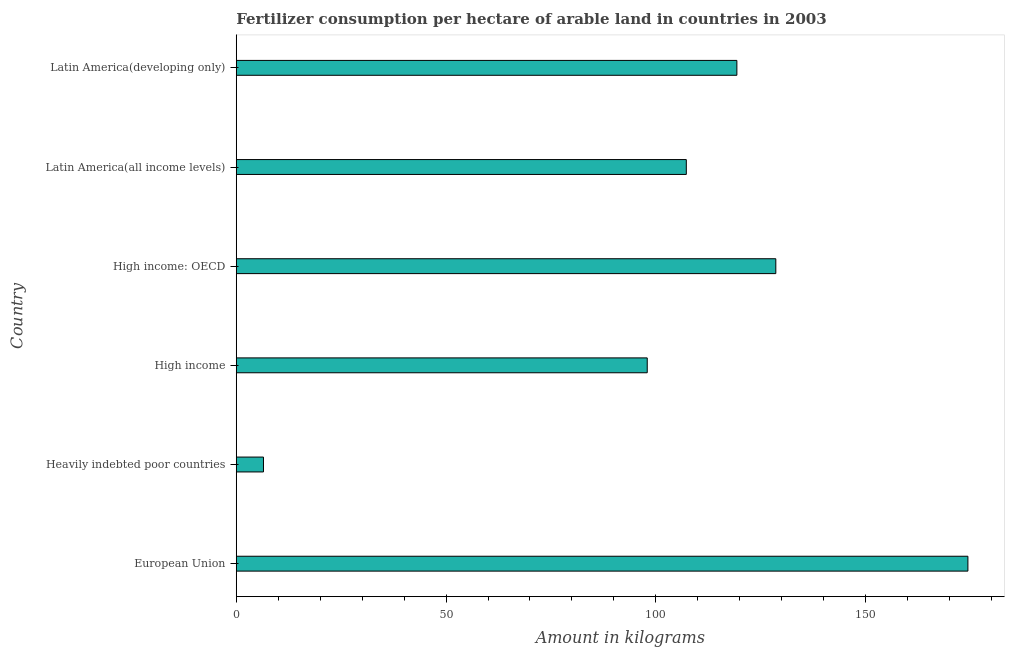Does the graph contain grids?
Provide a succinct answer. No. What is the title of the graph?
Offer a very short reply. Fertilizer consumption per hectare of arable land in countries in 2003 . What is the label or title of the X-axis?
Make the answer very short. Amount in kilograms. What is the amount of fertilizer consumption in Heavily indebted poor countries?
Provide a short and direct response. 6.48. Across all countries, what is the maximum amount of fertilizer consumption?
Ensure brevity in your answer.  174.38. Across all countries, what is the minimum amount of fertilizer consumption?
Ensure brevity in your answer.  6.48. In which country was the amount of fertilizer consumption maximum?
Provide a short and direct response. European Union. In which country was the amount of fertilizer consumption minimum?
Make the answer very short. Heavily indebted poor countries. What is the sum of the amount of fertilizer consumption?
Give a very brief answer. 633.98. What is the difference between the amount of fertilizer consumption in European Union and Latin America(developing only)?
Your response must be concise. 55.06. What is the average amount of fertilizer consumption per country?
Offer a terse response. 105.66. What is the median amount of fertilizer consumption?
Give a very brief answer. 113.29. In how many countries, is the amount of fertilizer consumption greater than 30 kg?
Offer a terse response. 5. What is the ratio of the amount of fertilizer consumption in European Union to that in High income: OECD?
Keep it short and to the point. 1.36. What is the difference between the highest and the second highest amount of fertilizer consumption?
Offer a terse response. 45.78. Is the sum of the amount of fertilizer consumption in European Union and High income: OECD greater than the maximum amount of fertilizer consumption across all countries?
Offer a very short reply. Yes. What is the difference between the highest and the lowest amount of fertilizer consumption?
Ensure brevity in your answer.  167.89. In how many countries, is the amount of fertilizer consumption greater than the average amount of fertilizer consumption taken over all countries?
Offer a terse response. 4. What is the difference between two consecutive major ticks on the X-axis?
Provide a short and direct response. 50. Are the values on the major ticks of X-axis written in scientific E-notation?
Your answer should be compact. No. What is the Amount in kilograms in European Union?
Your answer should be compact. 174.38. What is the Amount in kilograms in Heavily indebted poor countries?
Keep it short and to the point. 6.48. What is the Amount in kilograms in High income?
Your answer should be very brief. 97.95. What is the Amount in kilograms in High income: OECD?
Offer a very short reply. 128.59. What is the Amount in kilograms in Latin America(all income levels)?
Provide a succinct answer. 107.26. What is the Amount in kilograms of Latin America(developing only)?
Provide a short and direct response. 119.31. What is the difference between the Amount in kilograms in European Union and Heavily indebted poor countries?
Ensure brevity in your answer.  167.89. What is the difference between the Amount in kilograms in European Union and High income?
Provide a succinct answer. 76.43. What is the difference between the Amount in kilograms in European Union and High income: OECD?
Ensure brevity in your answer.  45.78. What is the difference between the Amount in kilograms in European Union and Latin America(all income levels)?
Your answer should be very brief. 67.11. What is the difference between the Amount in kilograms in European Union and Latin America(developing only)?
Your answer should be compact. 55.06. What is the difference between the Amount in kilograms in Heavily indebted poor countries and High income?
Your answer should be compact. -91.46. What is the difference between the Amount in kilograms in Heavily indebted poor countries and High income: OECD?
Your answer should be compact. -122.11. What is the difference between the Amount in kilograms in Heavily indebted poor countries and Latin America(all income levels)?
Ensure brevity in your answer.  -100.78. What is the difference between the Amount in kilograms in Heavily indebted poor countries and Latin America(developing only)?
Offer a terse response. -112.83. What is the difference between the Amount in kilograms in High income and High income: OECD?
Offer a very short reply. -30.64. What is the difference between the Amount in kilograms in High income and Latin America(all income levels)?
Ensure brevity in your answer.  -9.31. What is the difference between the Amount in kilograms in High income and Latin America(developing only)?
Provide a short and direct response. -21.36. What is the difference between the Amount in kilograms in High income: OECD and Latin America(all income levels)?
Provide a short and direct response. 21.33. What is the difference between the Amount in kilograms in High income: OECD and Latin America(developing only)?
Provide a succinct answer. 9.28. What is the difference between the Amount in kilograms in Latin America(all income levels) and Latin America(developing only)?
Provide a short and direct response. -12.05. What is the ratio of the Amount in kilograms in European Union to that in Heavily indebted poor countries?
Your response must be concise. 26.89. What is the ratio of the Amount in kilograms in European Union to that in High income?
Keep it short and to the point. 1.78. What is the ratio of the Amount in kilograms in European Union to that in High income: OECD?
Make the answer very short. 1.36. What is the ratio of the Amount in kilograms in European Union to that in Latin America(all income levels)?
Provide a short and direct response. 1.63. What is the ratio of the Amount in kilograms in European Union to that in Latin America(developing only)?
Your response must be concise. 1.46. What is the ratio of the Amount in kilograms in Heavily indebted poor countries to that in High income?
Offer a very short reply. 0.07. What is the ratio of the Amount in kilograms in Heavily indebted poor countries to that in Latin America(developing only)?
Offer a very short reply. 0.05. What is the ratio of the Amount in kilograms in High income to that in High income: OECD?
Your answer should be compact. 0.76. What is the ratio of the Amount in kilograms in High income to that in Latin America(developing only)?
Offer a terse response. 0.82. What is the ratio of the Amount in kilograms in High income: OECD to that in Latin America(all income levels)?
Your response must be concise. 1.2. What is the ratio of the Amount in kilograms in High income: OECD to that in Latin America(developing only)?
Offer a very short reply. 1.08. What is the ratio of the Amount in kilograms in Latin America(all income levels) to that in Latin America(developing only)?
Offer a very short reply. 0.9. 